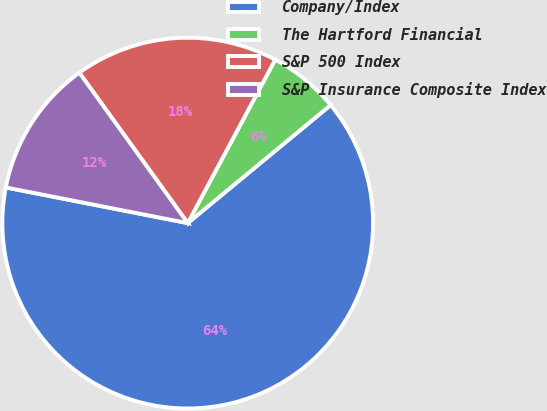Convert chart to OTSL. <chart><loc_0><loc_0><loc_500><loc_500><pie_chart><fcel>Company/Index<fcel>The Hartford Financial<fcel>S&P 500 Index<fcel>S&P Insurance Composite Index<nl><fcel>64.07%<fcel>6.19%<fcel>17.76%<fcel>11.98%<nl></chart> 